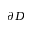<formula> <loc_0><loc_0><loc_500><loc_500>\partial D</formula> 